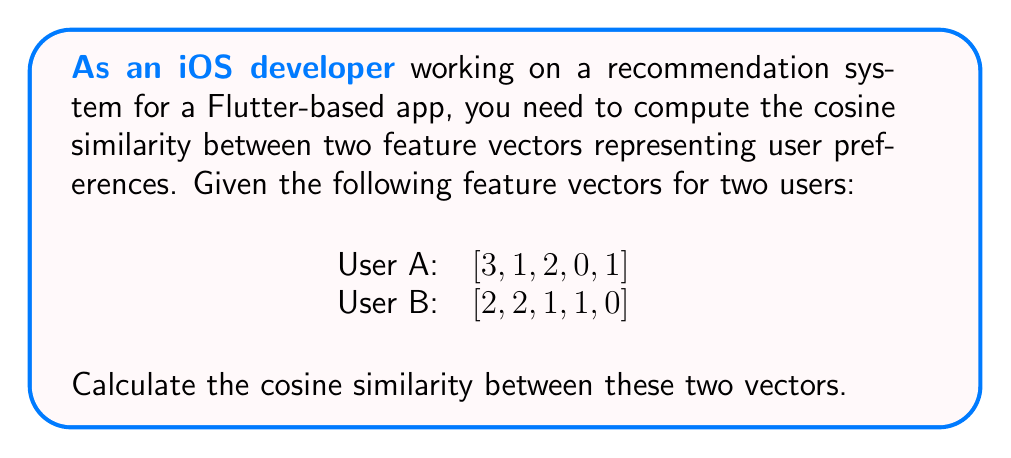Teach me how to tackle this problem. To compute the cosine similarity between two vectors, we'll follow these steps:

1) The cosine similarity formula is:

   $$\text{cosine similarity} = \frac{\mathbf{A} \cdot \mathbf{B}}{\|\mathbf{A}\| \|\mathbf{B}\|}$$

   Where $\mathbf{A} \cdot \mathbf{B}$ is the dot product, and $\|\mathbf{A}\|$ and $\|\mathbf{B}\|$ are the magnitudes of vectors A and B.

2) Calculate the dot product $\mathbf{A} \cdot \mathbf{B}$:
   $$(3 \times 2) + (1 \times 2) + (2 \times 1) + (0 \times 1) + (1 \times 0) = 6 + 2 + 2 + 0 + 0 = 10$$

3) Calculate $\|\mathbf{A}\|$:
   $$\|\mathbf{A}\| = \sqrt{3^2 + 1^2 + 2^2 + 0^2 + 1^2} = \sqrt{9 + 1 + 4 + 0 + 1} = \sqrt{15}$$

4) Calculate $\|\mathbf{B}\|$:
   $$\|\mathbf{B}\| = \sqrt{2^2 + 2^2 + 1^2 + 1^2 + 0^2} = \sqrt{4 + 4 + 1 + 1 + 0} = \sqrt{10}$$

5) Apply the cosine similarity formula:
   $$\text{cosine similarity} = \frac{10}{\sqrt{15} \times \sqrt{10}} = \frac{10}{\sqrt{150}}$$

6) Simplify:
   $$\frac{10}{\sqrt{150}} = \frac{10}{\sqrt{25 \times 6}} = \frac{10}{5\sqrt{6}} = \frac{2}{\sqrt{6}}$$

Therefore, the cosine similarity between the two feature vectors is $\frac{2}{\sqrt{6}}$.
Answer: $\frac{2}{\sqrt{6}}$ 